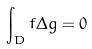Convert formula to latex. <formula><loc_0><loc_0><loc_500><loc_500>\int _ { D } f \Delta g = 0</formula> 